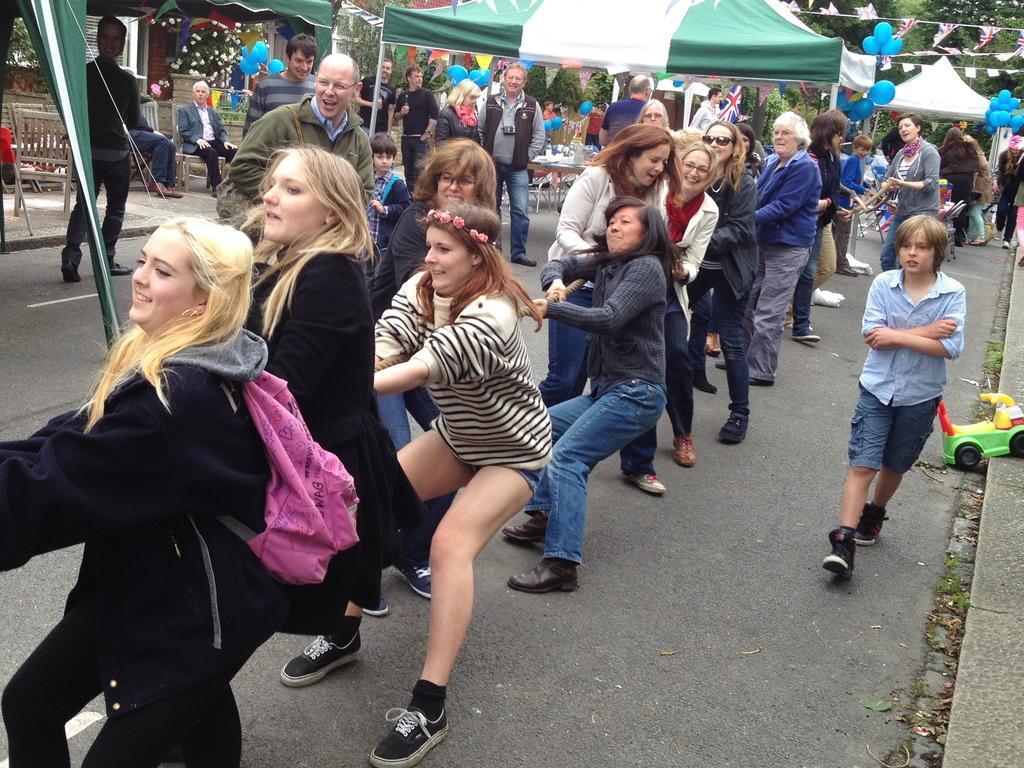Could you give a brief overview of what you see in this image? In the center of the image we can see people pulling the rope. On the right there is a boy walking. In the background there are people standing and we can see tents, balloons and trees. On the left there are benches. 